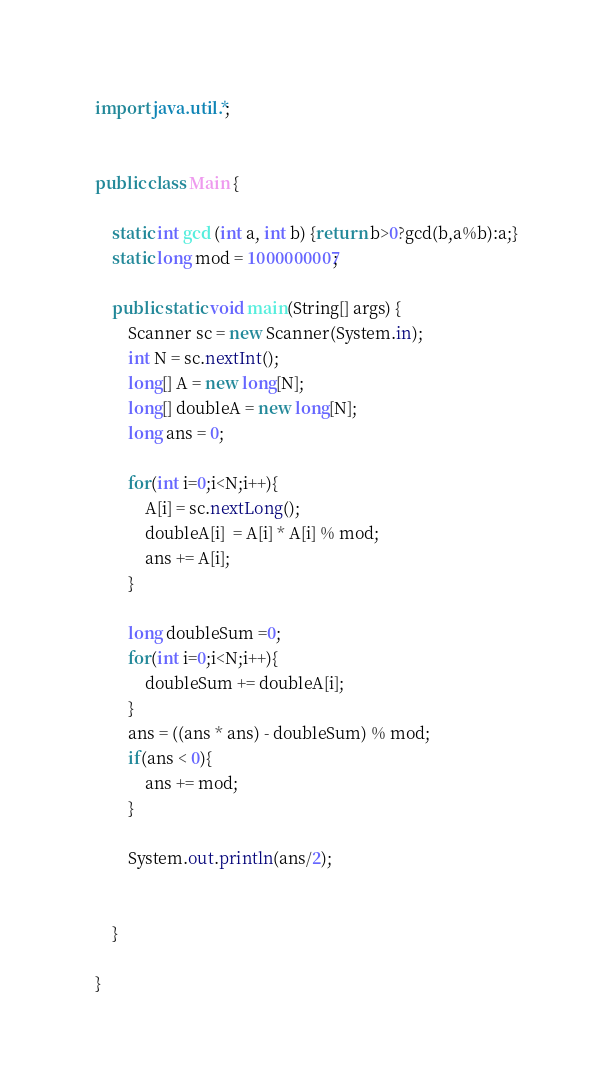Convert code to text. <code><loc_0><loc_0><loc_500><loc_500><_Java_>import java.util.*;


public class Main {

    static int gcd (int a, int b) {return b>0?gcd(b,a%b):a;}
    static long mod = 1000000007;

    public static void main(String[] args) {
        Scanner sc = new Scanner(System.in);
        int N = sc.nextInt();
        long[] A = new long[N];
        long[] doubleA = new long[N];
        long ans = 0;

        for(int i=0;i<N;i++){
            A[i] = sc.nextLong();
            doubleA[i]  = A[i] * A[i] % mod;
            ans += A[i];
        }

        long doubleSum =0;
        for(int i=0;i<N;i++){
            doubleSum += doubleA[i];
        }
        ans = ((ans * ans) - doubleSum) % mod;
        if(ans < 0){
            ans += mod;
        }

        System.out.println(ans/2);


    }

}


</code> 